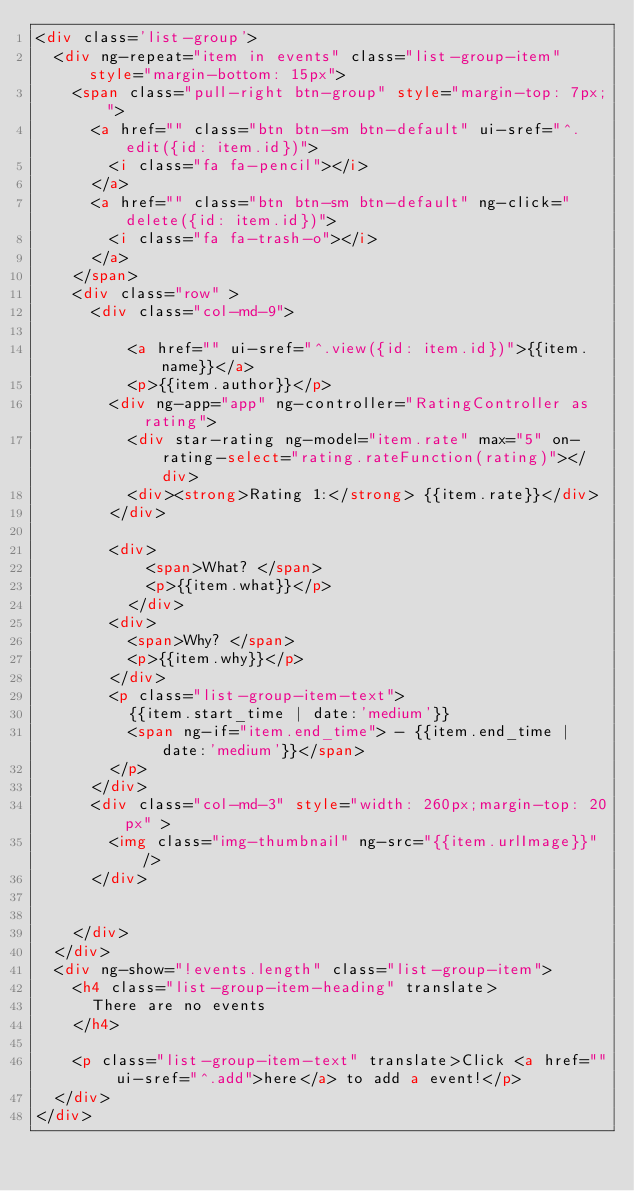<code> <loc_0><loc_0><loc_500><loc_500><_HTML_><div class='list-group'>
  <div ng-repeat="item in events" class="list-group-item" style="margin-bottom: 15px">
    <span class="pull-right btn-group" style="margin-top: 7px;">
      <a href="" class="btn btn-sm btn-default" ui-sref="^.edit({id: item.id})">
        <i class="fa fa-pencil"></i>
      </a>
      <a href="" class="btn btn-sm btn-default" ng-click="delete({id: item.id})">
        <i class="fa fa-trash-o"></i>
      </a>
    </span>
    <div class="row" >
      <div class="col-md-9">

          <a href="" ui-sref="^.view({id: item.id})">{{item.name}}</a>
          <p>{{item.author}}</p>
        <div ng-app="app" ng-controller="RatingController as rating">
          <div star-rating ng-model="item.rate" max="5" on-rating-select="rating.rateFunction(rating)"></div>
          <div><strong>Rating 1:</strong> {{item.rate}}</div>
        </div>

        <div>
            <span>What? </span>
            <p>{{item.what}}</p>
          </div>
        <div>
          <span>Why? </span>
          <p>{{item.why}}</p>
        </div>
        <p class="list-group-item-text">
          {{item.start_time | date:'medium'}}
          <span ng-if="item.end_time"> - {{item.end_time | date:'medium'}}</span>
        </p>
      </div>
      <div class="col-md-3" style="width: 260px;margin-top: 20px" >
        <img class="img-thumbnail" ng-src="{{item.urlImage}}"/>
      </div>


    </div>
  </div>
  <div ng-show="!events.length" class="list-group-item">
    <h4 class="list-group-item-heading" translate>
      There are no events
    </h4>

    <p class="list-group-item-text" translate>Click <a href="" ui-sref="^.add">here</a> to add a event!</p>
  </div>
</div>
</code> 